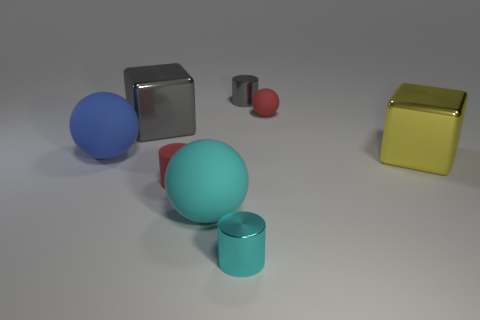What number of other objects are there of the same color as the small matte cylinder?
Give a very brief answer. 1. There is a blue ball; is it the same size as the metallic cylinder that is behind the gray block?
Ensure brevity in your answer.  No. There is a metallic block that is in front of the blue thing; is its size the same as the small gray metal object?
Offer a very short reply. No. What number of other objects are there of the same material as the cyan cylinder?
Ensure brevity in your answer.  3. Are there the same number of shiny cylinders that are in front of the large gray shiny cube and yellow metallic objects that are on the left side of the blue rubber object?
Offer a very short reply. No. There is a big object that is in front of the tiny matte object in front of the big cube that is left of the big cyan rubber ball; what is its color?
Provide a short and direct response. Cyan. What is the shape of the big cyan thing that is in front of the small red ball?
Provide a succinct answer. Sphere. What shape is the other big thing that is made of the same material as the big cyan thing?
Offer a very short reply. Sphere. Are there any other things that are the same shape as the large yellow metal thing?
Your answer should be compact. Yes. There is a small red sphere; what number of gray things are behind it?
Give a very brief answer. 1. 